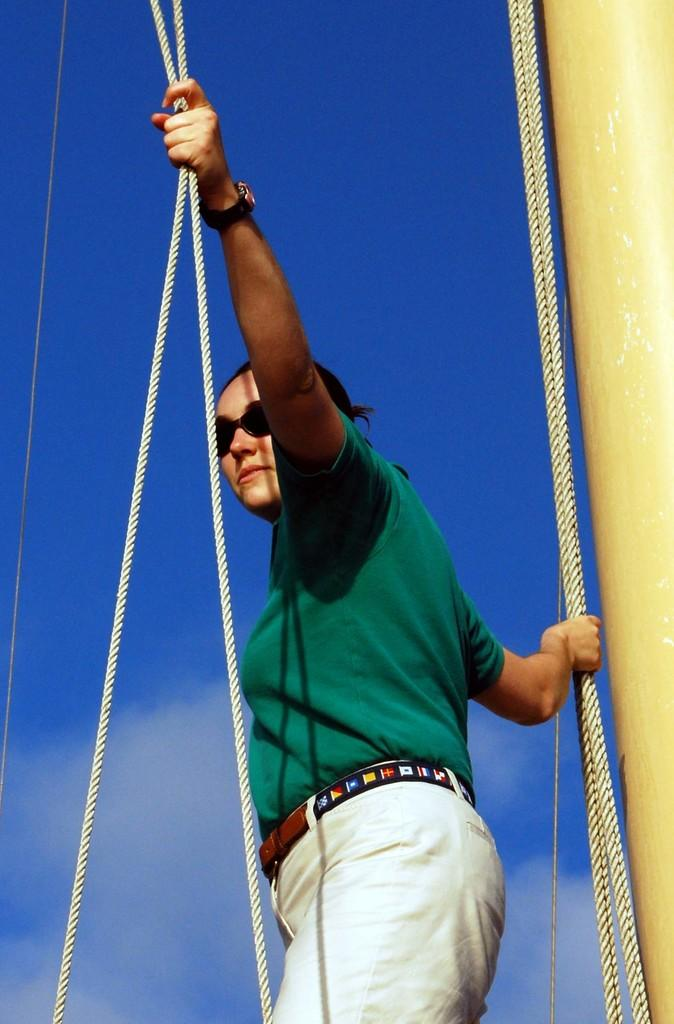Who is present in the image? There is a woman in the image. What is the woman doing in the image? The woman is standing and holding ropes. What can be seen in the right corner of the image? There is a pillar in the right corner of the image. What is visible in the background of the image? The sky is visible in the background of the image. What type of letter is the woman writing in the image? There is no letter present in the image; the woman is holding ropes. Where is the tub located in the image? There is no tub present in the image. 